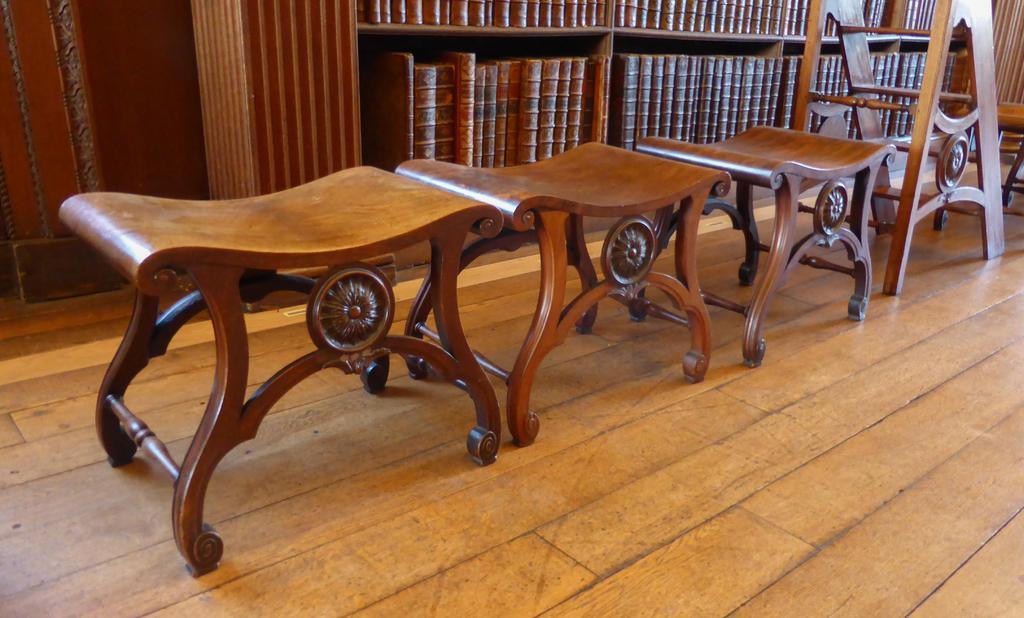Can you describe this image briefly? In this picture we can see there are wooden tables on the floor and on the right side of the tables, it looks like a wooden ladder. Behind the wooden tables there are some objects in the racks. 